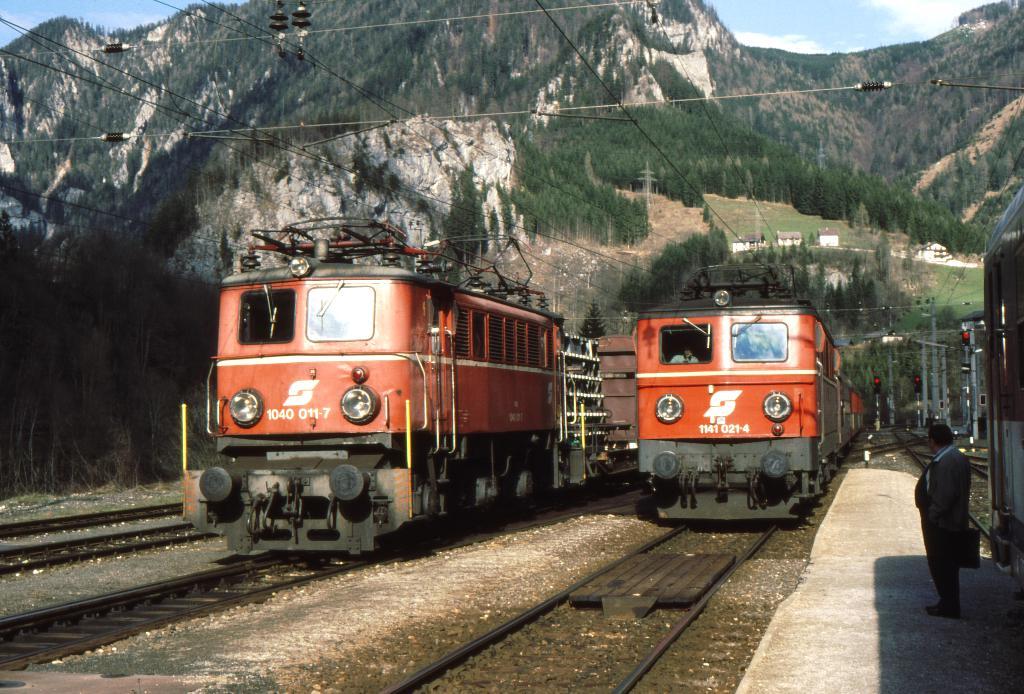What is the number on the train on the right?
Make the answer very short. 1141 021-4. 